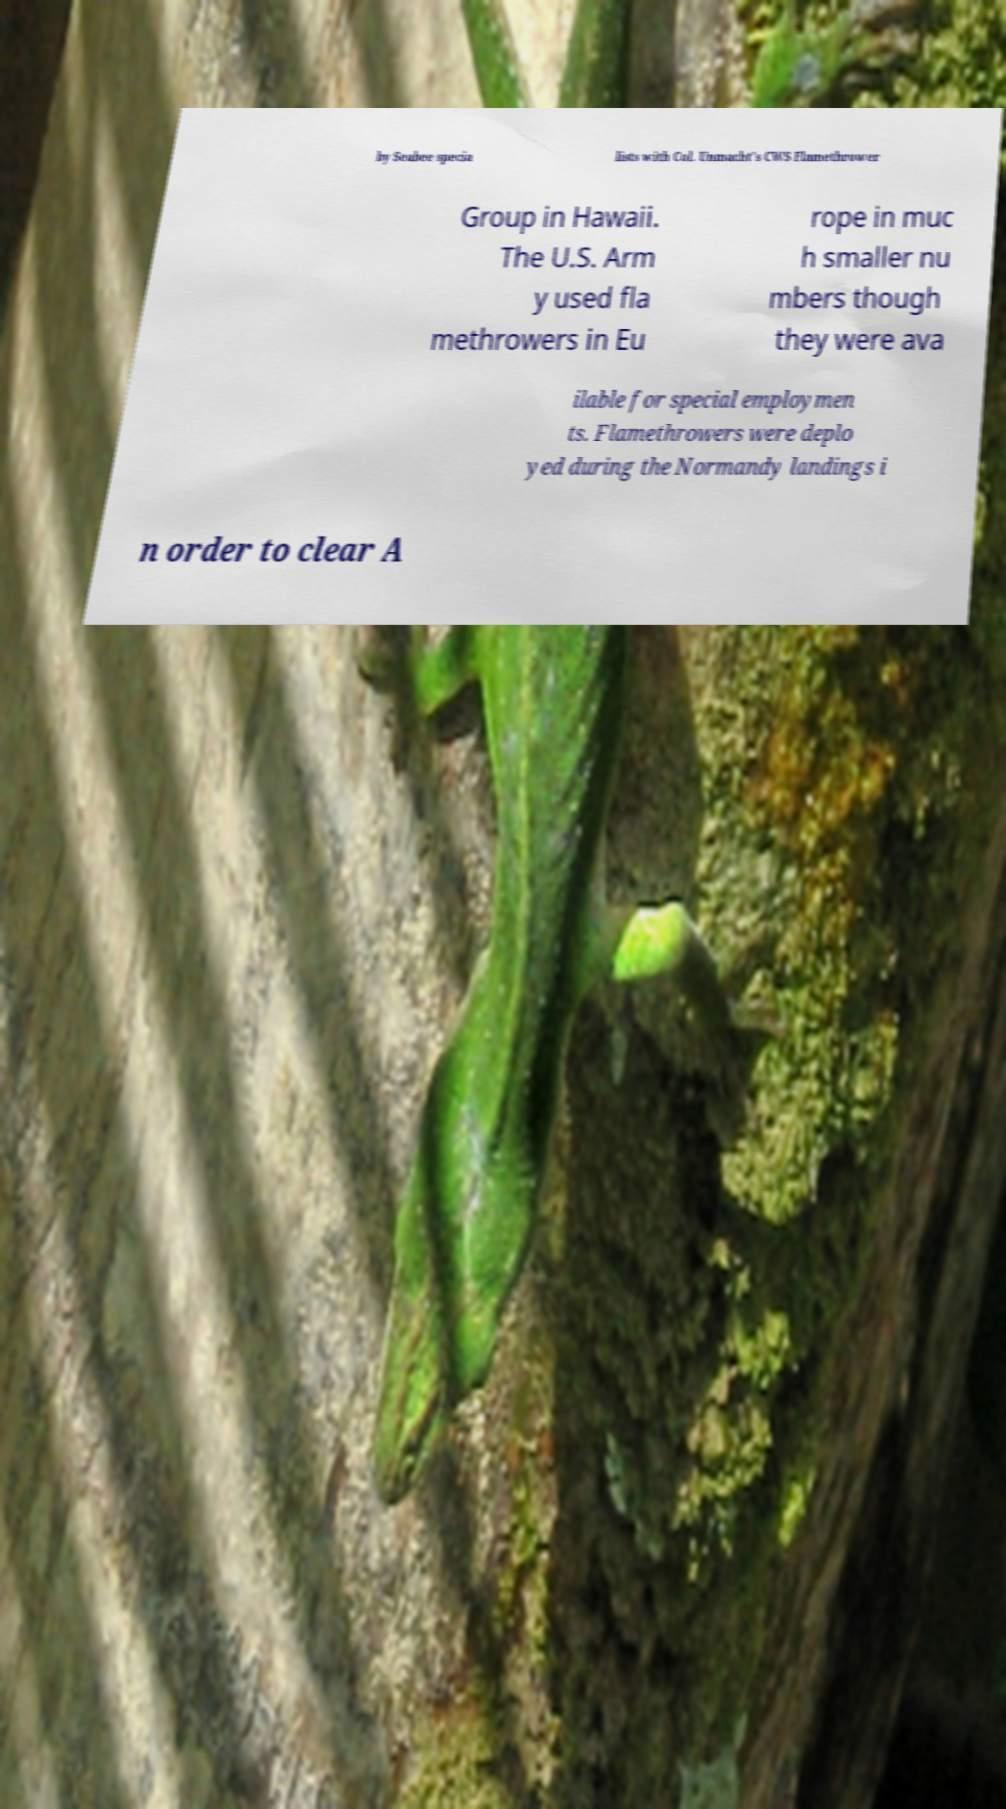There's text embedded in this image that I need extracted. Can you transcribe it verbatim? by Seabee specia lists with Col. Unmacht's CWS Flamethrower Group in Hawaii. The U.S. Arm y used fla methrowers in Eu rope in muc h smaller nu mbers though they were ava ilable for special employmen ts. Flamethrowers were deplo yed during the Normandy landings i n order to clear A 